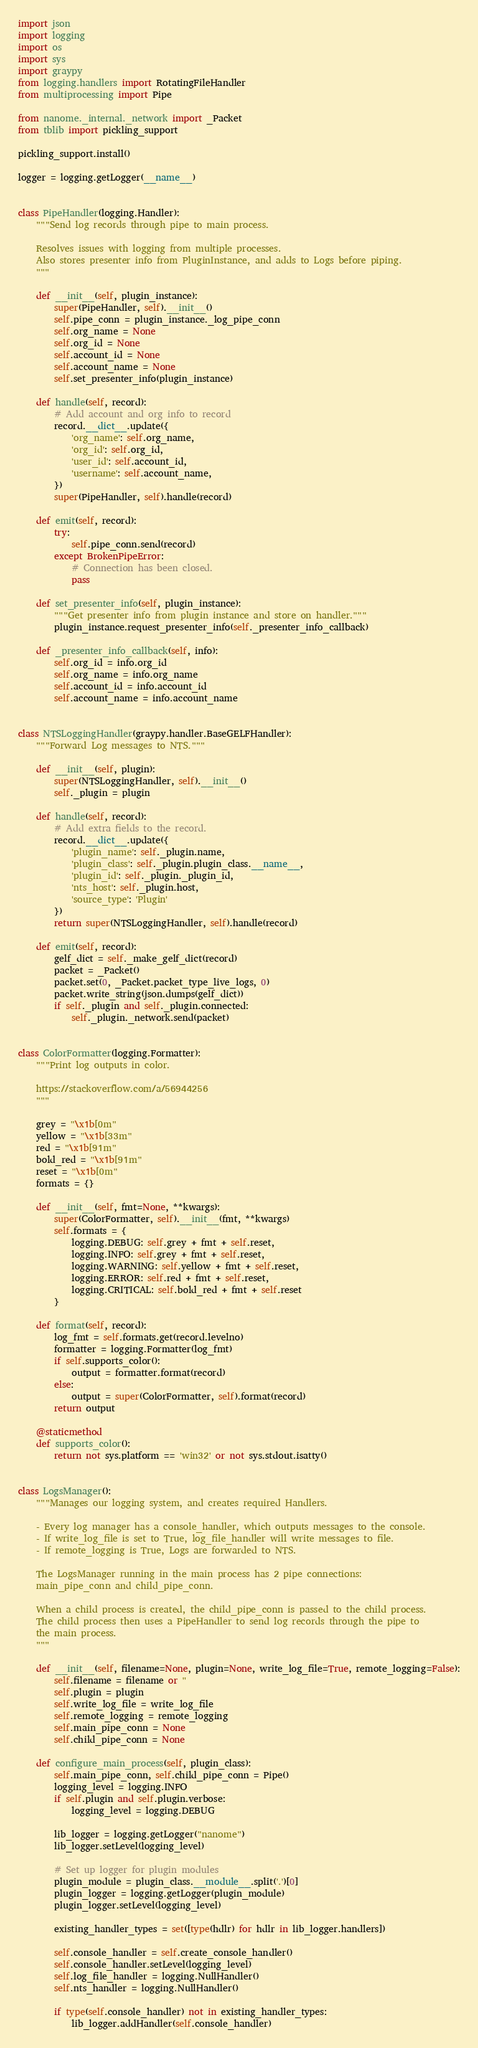Convert code to text. <code><loc_0><loc_0><loc_500><loc_500><_Python_>import json
import logging
import os
import sys
import graypy
from logging.handlers import RotatingFileHandler
from multiprocessing import Pipe

from nanome._internal._network import _Packet
from tblib import pickling_support

pickling_support.install()

logger = logging.getLogger(__name__)


class PipeHandler(logging.Handler):
    """Send log records through pipe to main process.

    Resolves issues with logging from multiple processes.
    Also stores presenter info from PluginInstance, and adds to Logs before piping.
    """

    def __init__(self, plugin_instance):
        super(PipeHandler, self).__init__()
        self.pipe_conn = plugin_instance._log_pipe_conn
        self.org_name = None
        self.org_id = None
        self.account_id = None
        self.account_name = None
        self.set_presenter_info(plugin_instance)

    def handle(self, record):
        # Add account and org info to record
        record.__dict__.update({
            'org_name': self.org_name,
            'org_id': self.org_id,
            'user_id': self.account_id,
            'username': self.account_name,
        })
        super(PipeHandler, self).handle(record)

    def emit(self, record):
        try:
            self.pipe_conn.send(record)
        except BrokenPipeError:
            # Connection has been closed.
            pass

    def set_presenter_info(self, plugin_instance):
        """Get presenter info from plugin instance and store on handler."""
        plugin_instance.request_presenter_info(self._presenter_info_callback)

    def _presenter_info_callback(self, info):
        self.org_id = info.org_id
        self.org_name = info.org_name
        self.account_id = info.account_id
        self.account_name = info.account_name


class NTSLoggingHandler(graypy.handler.BaseGELFHandler):
    """Forward Log messages to NTS."""

    def __init__(self, plugin):
        super(NTSLoggingHandler, self).__init__()
        self._plugin = plugin

    def handle(self, record):
        # Add extra fields to the record.
        record.__dict__.update({
            'plugin_name': self._plugin.name,
            'plugin_class': self._plugin.plugin_class.__name__,
            'plugin_id': self._plugin._plugin_id,
            'nts_host': self._plugin.host,
            'source_type': 'Plugin'
        })
        return super(NTSLoggingHandler, self).handle(record)

    def emit(self, record):
        gelf_dict = self._make_gelf_dict(record)
        packet = _Packet()
        packet.set(0, _Packet.packet_type_live_logs, 0)
        packet.write_string(json.dumps(gelf_dict))
        if self._plugin and self._plugin.connected:
            self._plugin._network.send(packet)


class ColorFormatter(logging.Formatter):
    """Print log outputs in color.

    https://stackoverflow.com/a/56944256
    """

    grey = "\x1b[0m"
    yellow = "\x1b[33m"
    red = "\x1b[91m"
    bold_red = "\x1b[91m"
    reset = "\x1b[0m"
    formats = {}

    def __init__(self, fmt=None, **kwargs):
        super(ColorFormatter, self).__init__(fmt, **kwargs)
        self.formats = {
            logging.DEBUG: self.grey + fmt + self.reset,
            logging.INFO: self.grey + fmt + self.reset,
            logging.WARNING: self.yellow + fmt + self.reset,
            logging.ERROR: self.red + fmt + self.reset,
            logging.CRITICAL: self.bold_red + fmt + self.reset
        }

    def format(self, record):
        log_fmt = self.formats.get(record.levelno)
        formatter = logging.Formatter(log_fmt)
        if self.supports_color():
            output = formatter.format(record)
        else:
            output = super(ColorFormatter, self).format(record)
        return output

    @staticmethod
    def supports_color():
        return not sys.platform == 'win32' or not sys.stdout.isatty()


class LogsManager():
    """Manages our logging system, and creates required Handlers.

    - Every log manager has a console_handler, which outputs messages to the console.
    - If write_log_file is set to True, log_file_handler will write messages to file.
    - If remote_logging is True, Logs are forwarded to NTS.

    The LogsManager running in the main process has 2 pipe connections:
    main_pipe_conn and child_pipe_conn.

    When a child process is created, the child_pipe_conn is passed to the child process.
    The child process then uses a PipeHandler to send log records through the pipe to
    the main process.
    """

    def __init__(self, filename=None, plugin=None, write_log_file=True, remote_logging=False):
        self.filename = filename or ''
        self.plugin = plugin
        self.write_log_file = write_log_file
        self.remote_logging = remote_logging
        self.main_pipe_conn = None
        self.child_pipe_conn = None

    def configure_main_process(self, plugin_class):
        self.main_pipe_conn, self.child_pipe_conn = Pipe()
        logging_level = logging.INFO
        if self.plugin and self.plugin.verbose:
            logging_level = logging.DEBUG

        lib_logger = logging.getLogger("nanome")
        lib_logger.setLevel(logging_level)

        # Set up logger for plugin modules
        plugin_module = plugin_class.__module__.split('.')[0]
        plugin_logger = logging.getLogger(plugin_module)
        plugin_logger.setLevel(logging_level)

        existing_handler_types = set([type(hdlr) for hdlr in lib_logger.handlers])

        self.console_handler = self.create_console_handler()
        self.console_handler.setLevel(logging_level)
        self.log_file_handler = logging.NullHandler()
        self.nts_handler = logging.NullHandler()

        if type(self.console_handler) not in existing_handler_types:
            lib_logger.addHandler(self.console_handler)</code> 